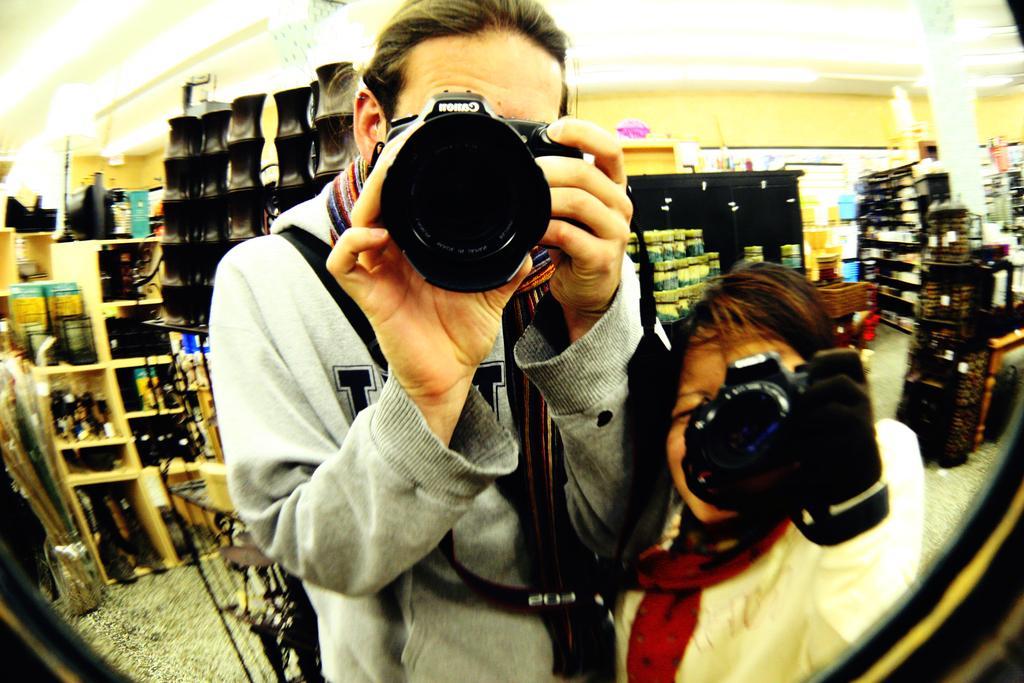Could you give a brief overview of what you see in this image? In this picture, In the middle there is a woman standing and holding a camera which is in black color, in the right side there is a girl standing and holding a camera, In the background there are some racks and there is a yellow color wall. 